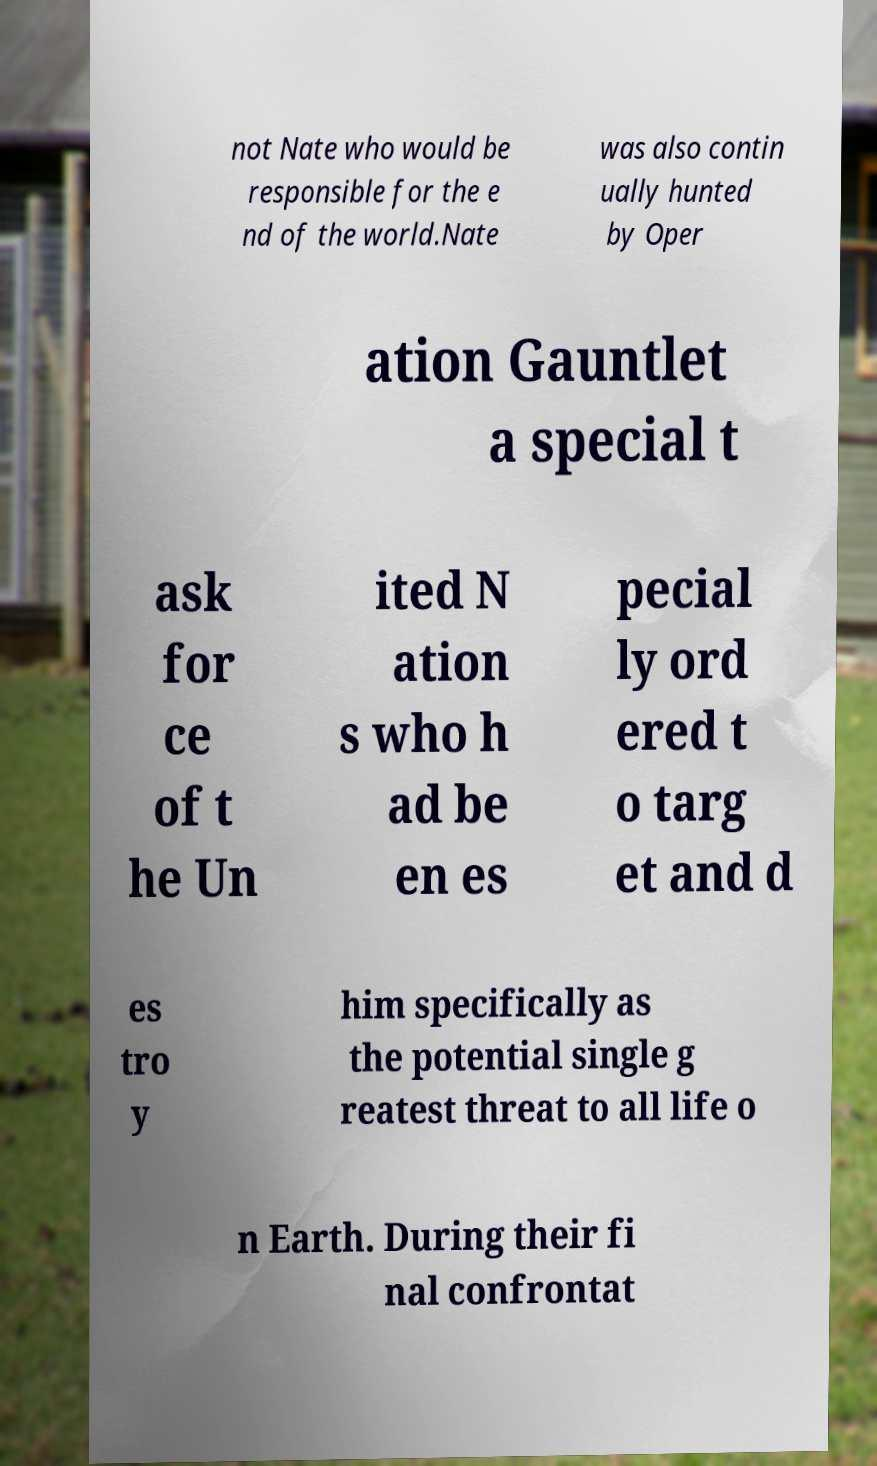Could you extract and type out the text from this image? not Nate who would be responsible for the e nd of the world.Nate was also contin ually hunted by Oper ation Gauntlet a special t ask for ce of t he Un ited N ation s who h ad be en es pecial ly ord ered t o targ et and d es tro y him specifically as the potential single g reatest threat to all life o n Earth. During their fi nal confrontat 